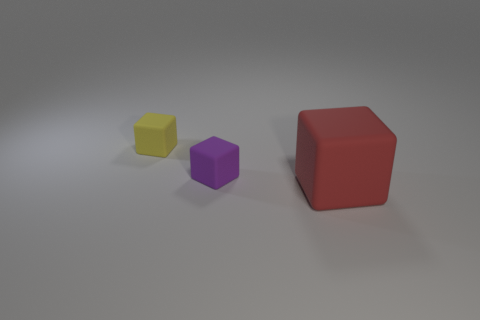Subtract all yellow cubes. Subtract all purple cylinders. How many cubes are left? 2 Add 1 rubber objects. How many objects exist? 4 Subtract 0 cyan spheres. How many objects are left? 3 Subtract all matte cubes. Subtract all brown rubber cylinders. How many objects are left? 0 Add 2 yellow things. How many yellow things are left? 3 Add 2 big rubber cubes. How many big rubber cubes exist? 3 